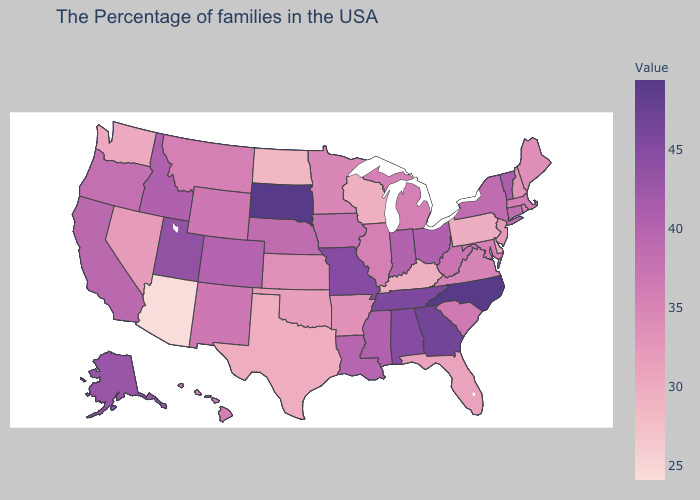Does Oregon have the lowest value in the USA?
Concise answer only. No. Which states have the highest value in the USA?
Keep it brief. North Carolina, South Dakota. Which states have the lowest value in the USA?
Be succinct. Arizona. Does North Carolina have the highest value in the USA?
Keep it brief. Yes. Does New Hampshire have the highest value in the Northeast?
Answer briefly. No. Does Arkansas have a higher value than Arizona?
Give a very brief answer. Yes. Does Massachusetts have the lowest value in the USA?
Answer briefly. No. 